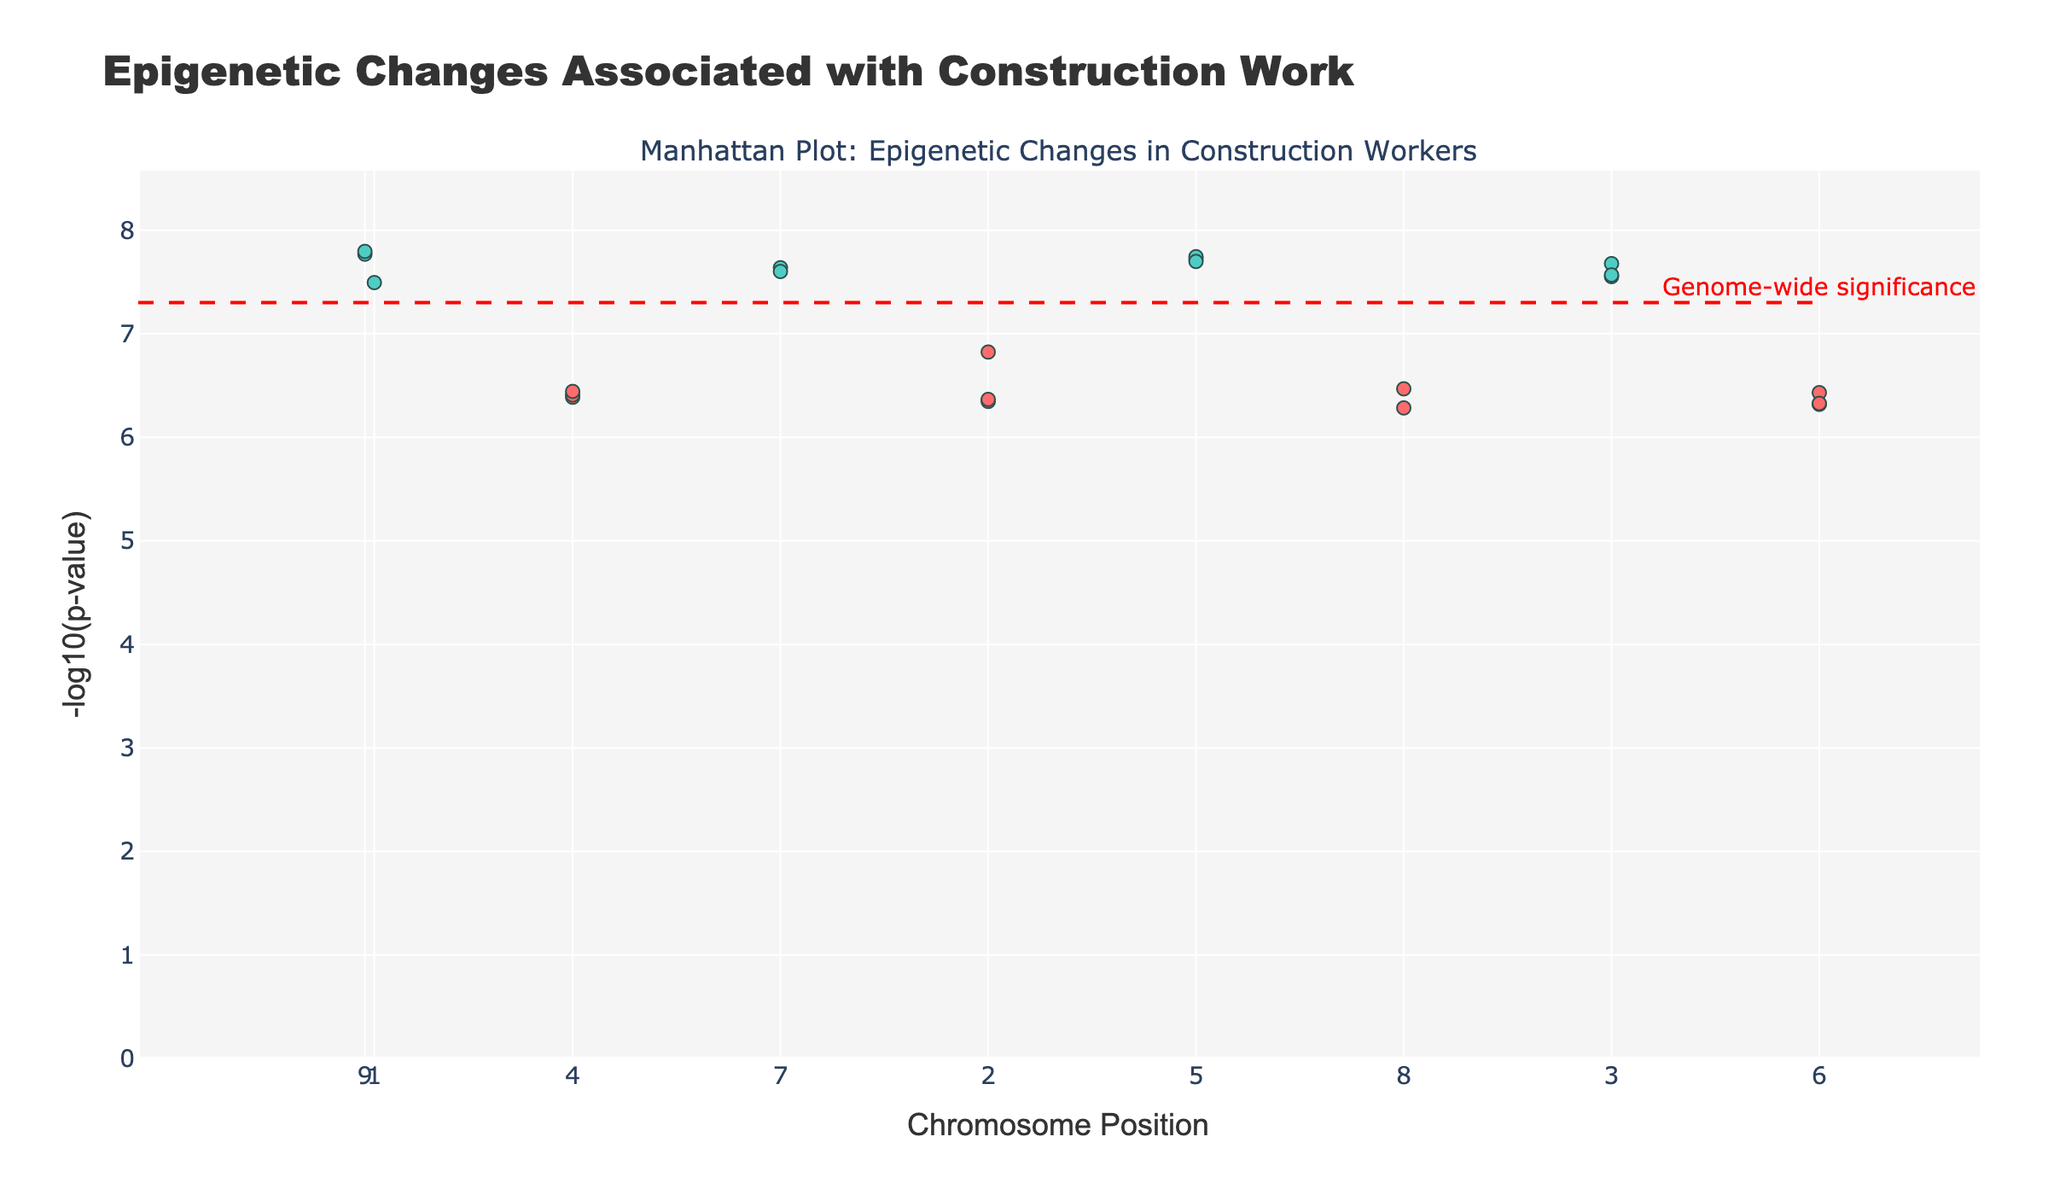What is the title of the figure? The title is typically displayed at the top of the figure and is meant to provide a succinct description of what the figure is about. In this case, the title describes the plot as showing epigenetic changes associated with construction work.
Answer: "Epigenetic Changes Associated with Construction Work" Which chromosome has the lowest p-value? To identify the chromosome with the lowest p-value, we examine the y-axis and find the data point with the highest -log10(p-value). We then look at the corresponding chromosomal label.
Answer: Chromosome 17 How many data points are displayed for Chromosome 6? Count the number of markers (dots) that fall under the label for Chromosome 6. Each represents a distinct data point.
Answer: One What color is used for Chromosome 1 in the plot? The color assigned to Chromosome 1 should be consistent for all its data points. We can observe this by looking at the scatter points labeled as Chromosome 1.
Answer: A shade of red What does the horizontal dashed red line represent? The plot includes a horizontal reference line annotated with text indicating its significance. The annotation and the placement of this line convey its meaning.
Answer: Genome-wide significance Which genes have p-values less than 5e-8? A p-value less than 5e-8 corresponds to a -log10(p-value) above -log10(5e-8). Identify the data points that exceed this threshold on the y-axis and note their associated gene labels.
Answer: DNMT1, HDAC1, SIRT1, TET1, KDM1A, DNMT3A, SETD7, SUV39H1, CHD1, EP300, HMGB1 Which data point is at the position 78000000 and which chromosome does it belong to? Find the data point located at the position value of 78000000 on the x-axis, then cross-reference to find out which chromosomal category it falls under.
Answer: Gene: SIRT1, Chromosome: 3 Is there any chromosome without any low p-value data points represented in the plot? Scan through each chromosomal label and ensure there are no significant markers (below the threshold line) for that chromosome. Consider only those with markers not breaching the significance line.
Answer: No, all chromosomes have at least one data point Which chromosome has the highest number of significant genes? Count the number of significant data points (below threshold line) attributed to each chromosome. Compare counts across chromosomes.
Answer: All chromosomes have one significant gene each 